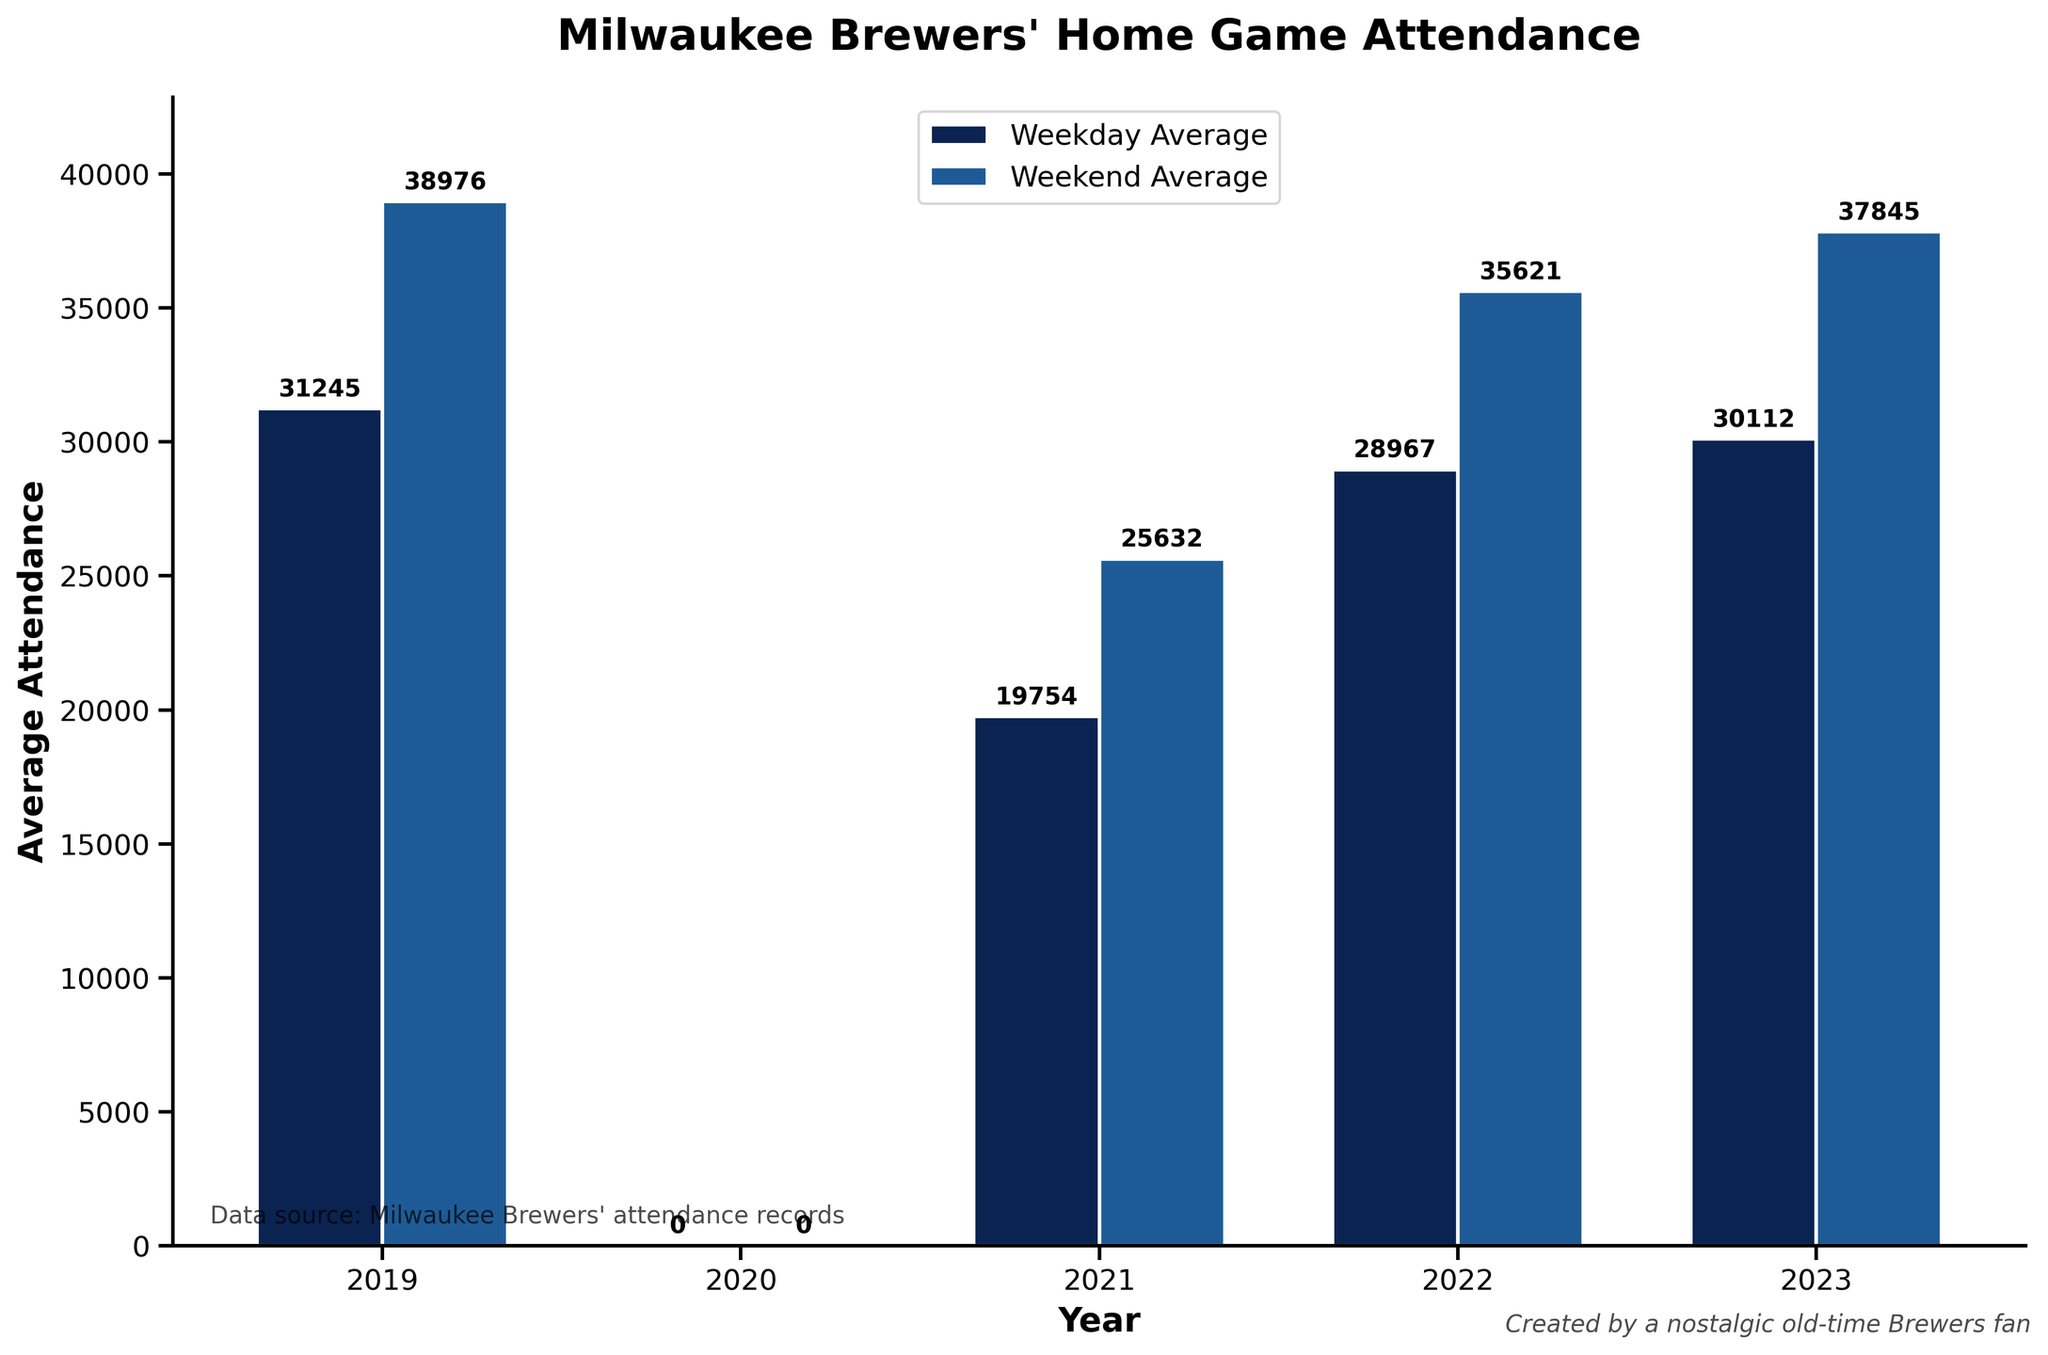What is the average attendance for the Brewers' weekday home games in 2021? Refer to the figure and read the "Weekday Average" bar for the year 2021. The average attendance for weekday games in 2021 is represented by the height of this bar.
Answer: 19754 Which year had the highest weekend average attendance? Referring to the "Weekend Average" bars for all years, identify the year with the tallest bar, indicating the highest weekend average attendance.
Answer: 2019 By how much did the average attendance for weekday games increase from 2021 to 2022? Subtract the average weekday attendance in 2021 from the figure for 2022. From the bars, 2021 had 19754 and 2022 had 28967. The difference is 28967 - 19754.
Answer: 9213 Which type of games generally had higher attendance, weekdays or weekends? Comprehensively compare the heights of the "Weekday Average" bars with the "Weekend Average" bars across all years. Weekend bars are consistently taller than weekday bars.
Answer: Weekends What was the difference in weekend average attendance between 2022 and 2023? Subtract the weekend average attendance in 2022 from that in 2023. From the bars, 2022 weekend average is 35621 and 2023 weekend average is 37845. The difference is 37845 - 35621.
Answer: 2224 In which year was the smallest difference between weekday and weekend attendance? Calculate the difference between weekend and weekday attendance for each year and identify the year with the smallest difference. For each year: 2019: 38976 - 31245 = 7731, 2021: 25632 - 19754 = 5878, 2022: 35621 - 28967 = 6654, 2023: 37845 - 30112 = 7733. The smallest difference is in 2021 with 5878.
Answer: 2021 What color represents the bars showing weekend average attendance in the figure? Look at the color of the bars labeled as "Weekend Average" in the figure. The weekend average attendance bars are shown in blue.
Answer: Blue How did the weekend average attendance change from 2019 to 2021? Compare the heights of the "Weekend Average" bars for 2019 and 2021. The bar for 2019 is taller than 2021. Subtract 2021 value (25632) from 2019 value (38976). The decrease is 38976 - 25632.
Answer: Decrease by 13344 